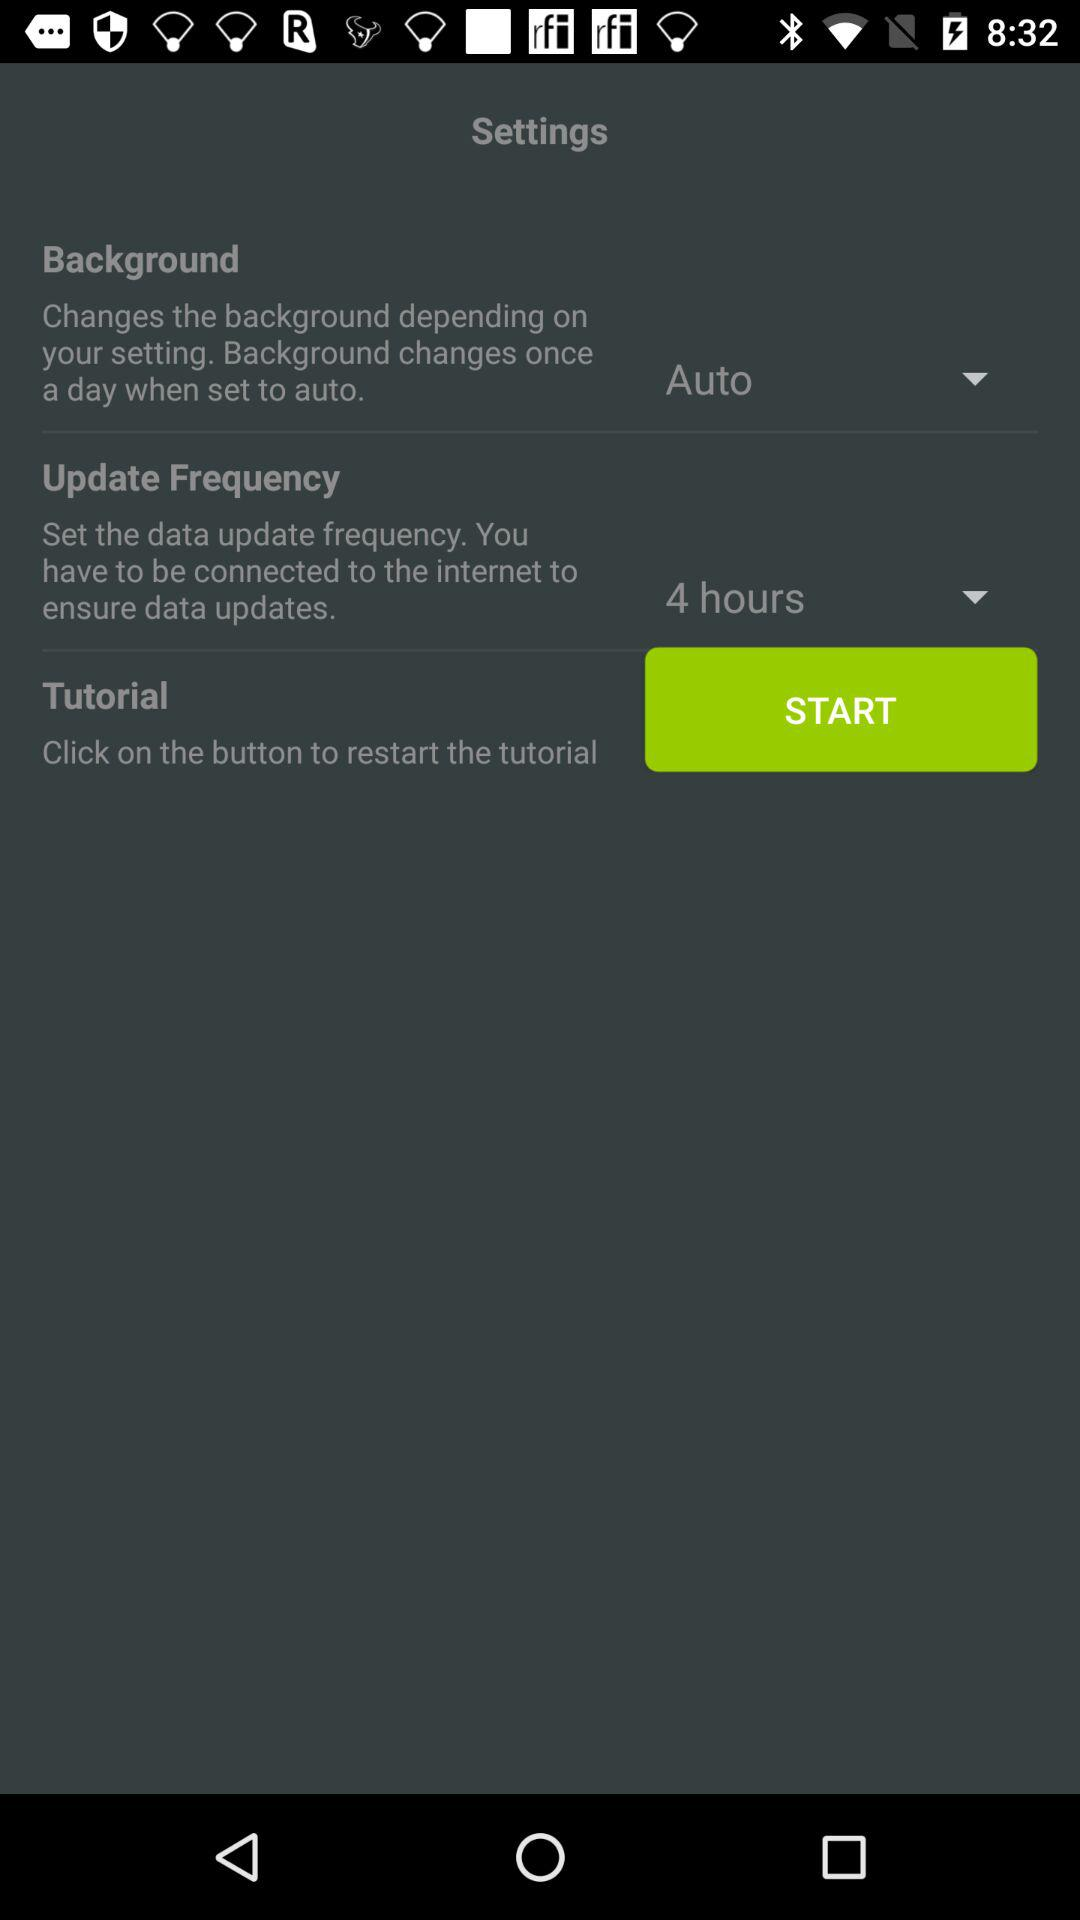How often does the frequency update? The frequency updates every 4 hours. 